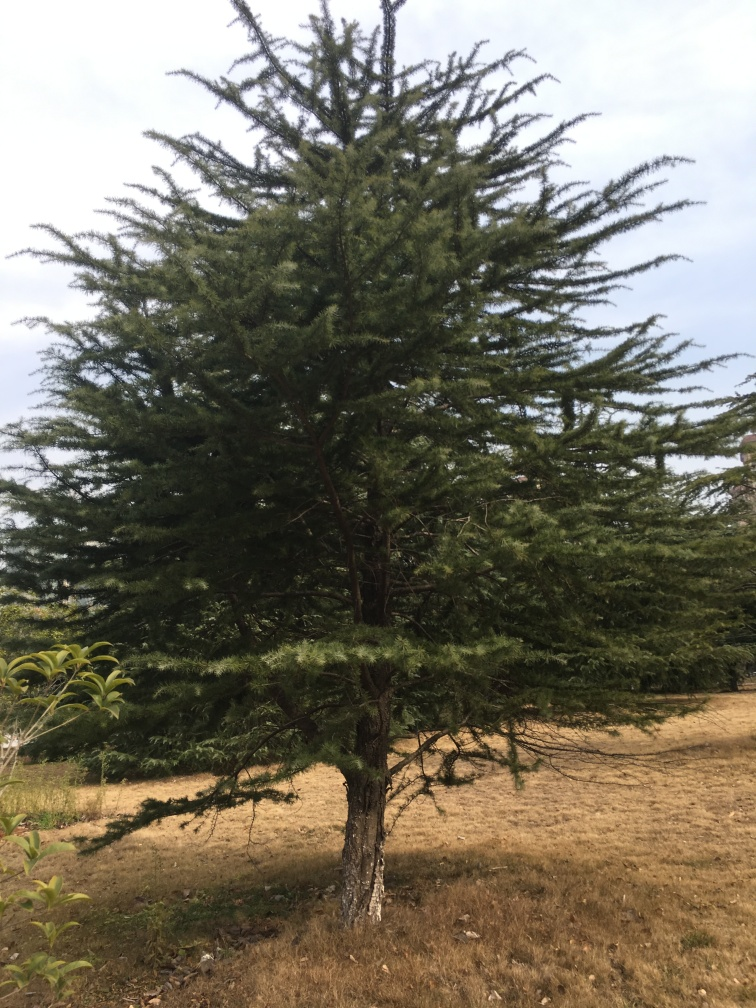Is this environment suitable for this tree? Yes, coniferous trees often thrive in a variety of environments. The tree appears healthy and robust with no visible signs of distress. The surrounding grassy area seems dry, indicating the tree may be adapted to less water-intensive soil conditions or that it has access to deeper water reserves. 